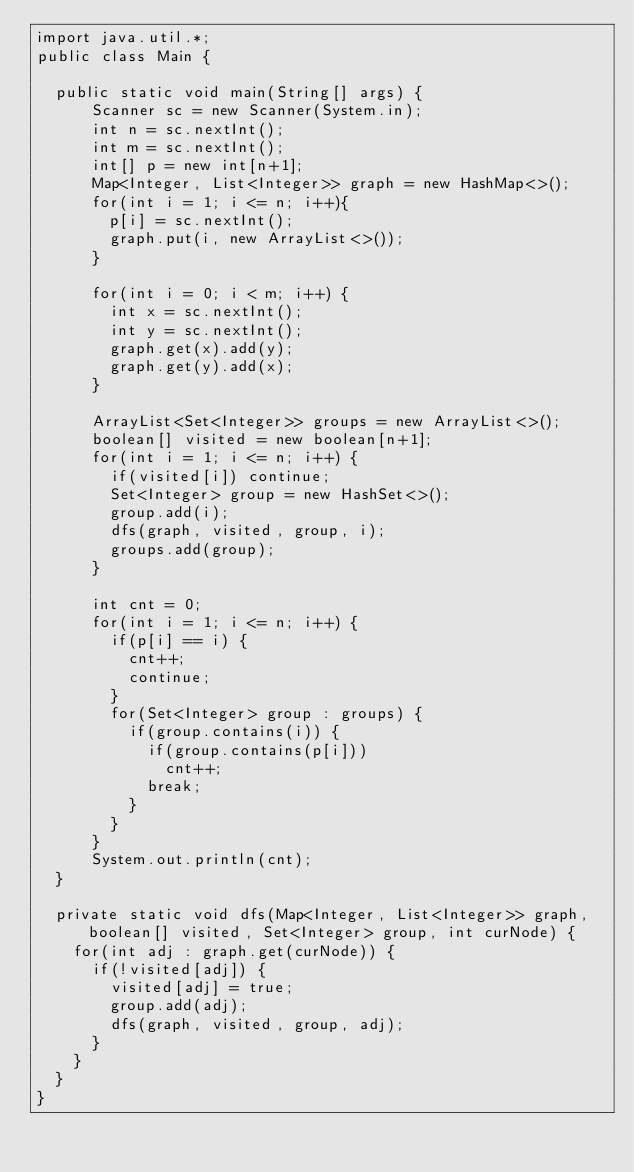Convert code to text. <code><loc_0><loc_0><loc_500><loc_500><_Java_>import java.util.*;
public class Main {

  public static void main(String[] args) { 
      Scanner sc = new Scanner(System.in);
      int n = sc.nextInt();
      int m = sc.nextInt();
      int[] p = new int[n+1];
      Map<Integer, List<Integer>> graph = new HashMap<>();
      for(int i = 1; i <= n; i++){
        p[i] = sc.nextInt();
        graph.put(i, new ArrayList<>());
      }

      for(int i = 0; i < m; i++) {
        int x = sc.nextInt();
        int y = sc.nextInt();
        graph.get(x).add(y);
        graph.get(y).add(x);
      }

      ArrayList<Set<Integer>> groups = new ArrayList<>();
      boolean[] visited = new boolean[n+1];
      for(int i = 1; i <= n; i++) {
        if(visited[i]) continue;
        Set<Integer> group = new HashSet<>();
        group.add(i);
        dfs(graph, visited, group, i);
        groups.add(group);
      }

      int cnt = 0;
      for(int i = 1; i <= n; i++) {
        if(p[i] == i) {
          cnt++;
          continue;
        }
        for(Set<Integer> group : groups) {
          if(group.contains(i)) {
            if(group.contains(p[i]))
              cnt++;
            break;
          }
        }
      }
      System.out.println(cnt);
  }

  private static void dfs(Map<Integer, List<Integer>> graph, boolean[] visited, Set<Integer> group, int curNode) {
    for(int adj : graph.get(curNode)) {
      if(!visited[adj]) {
        visited[adj] = true;
        group.add(adj);
        dfs(graph, visited, group, adj);
      }
    }
  }
}</code> 